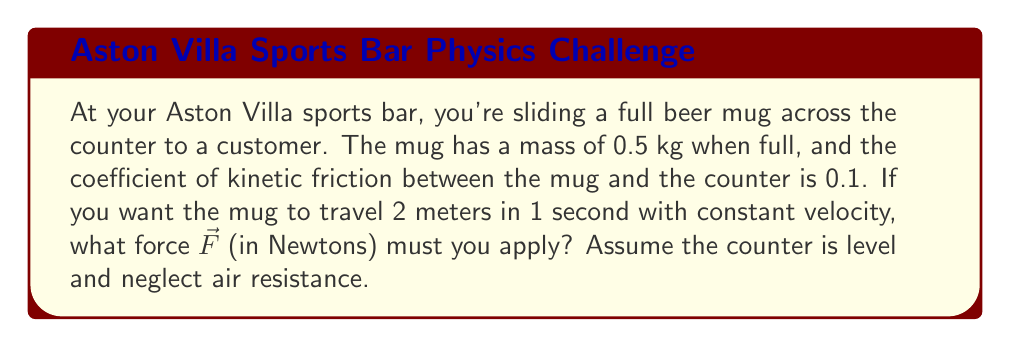Help me with this question. Let's approach this step-by-step:

1) First, we need to identify the forces acting on the mug:
   - The applied force $\vec{F}$ (what we're solving for)
   - The force of friction $\vec{f}$
   - The normal force $\vec{N}$
   - The force of gravity $\vec{g}$

2) Since the counter is level and the mug moves at constant velocity, we know:
   - The vertical forces balance out: $N = mg$
   - The horizontal forces must also balance: $F = f$

3) We can calculate the magnitude of the friction force using the coefficient of kinetic friction:

   $f = \mu N = \mu mg$

   where $\mu$ is the coefficient of kinetic friction, $m$ is the mass, and $g$ is the acceleration due to gravity (9.8 m/s²).

4) Substituting the known values:

   $f = 0.1 \times 0.5 \text{ kg} \times 9.8 \text{ m/s}^2 = 0.49 \text{ N}$

5) Since the mug moves at constant velocity, the applied force must equal the friction force:

   $F = f = 0.49 \text{ N}$

6) The direction of $\vec{F}$ is horizontal in the direction of motion, opposite to the friction force.

Therefore, the force required to slide the mug is 0.49 N in the horizontal direction of motion.

Note: The distance and time given (2 meters in 1 second) weren't necessary for this calculation, as the force required for constant velocity is independent of the speed or distance traveled.
Answer: $\vec{F} = 0.49 \text{ N}$ in the horizontal direction of motion 